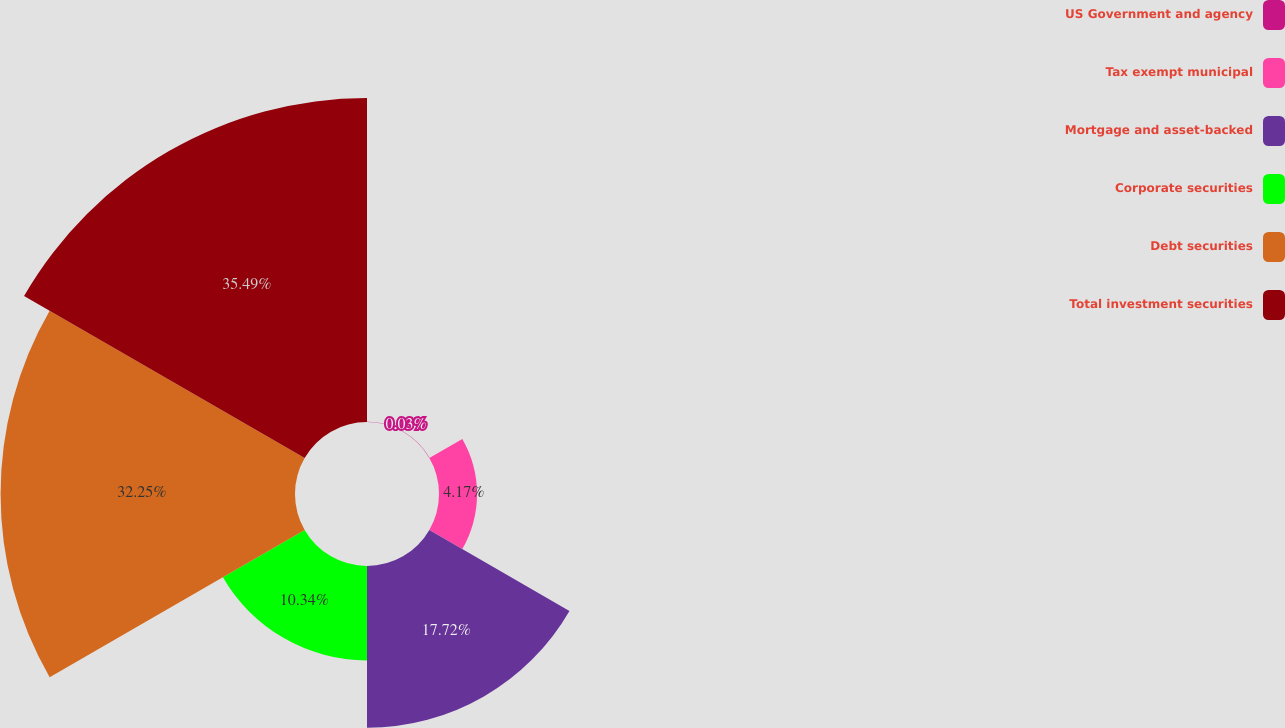Convert chart. <chart><loc_0><loc_0><loc_500><loc_500><pie_chart><fcel>US Government and agency<fcel>Tax exempt municipal<fcel>Mortgage and asset-backed<fcel>Corporate securities<fcel>Debt securities<fcel>Total investment securities<nl><fcel>0.03%<fcel>4.17%<fcel>17.72%<fcel>10.34%<fcel>32.25%<fcel>35.49%<nl></chart> 